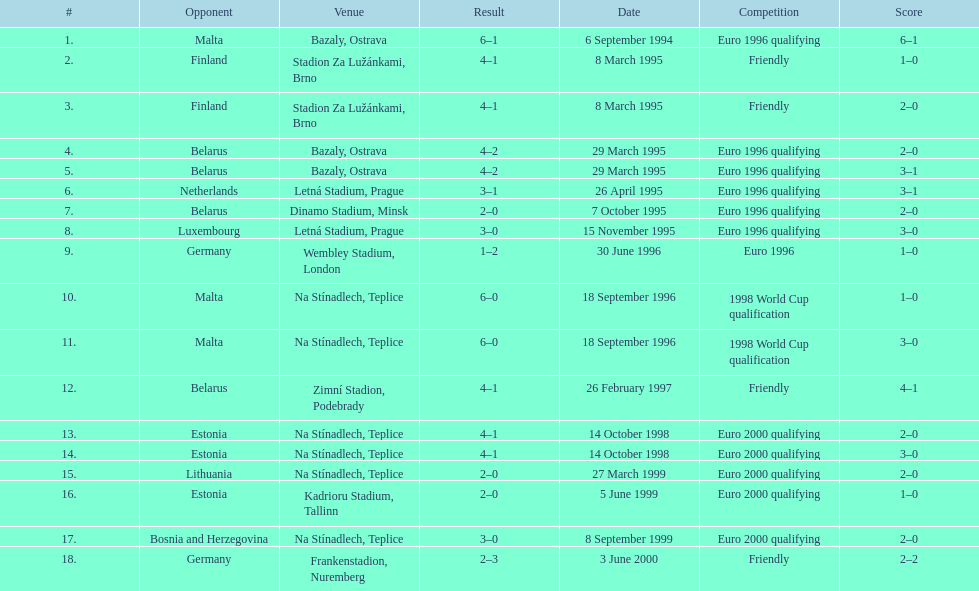Identify the participants involved in the friendly contest. Finland, Belarus, Germany. 